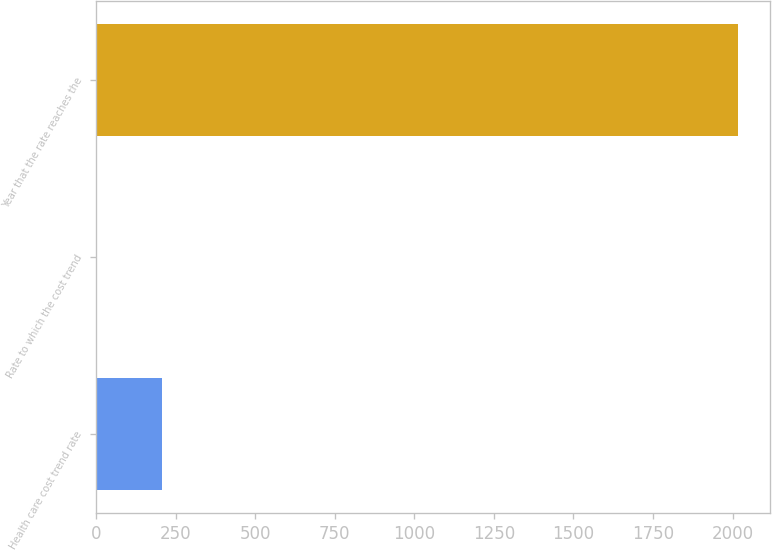<chart> <loc_0><loc_0><loc_500><loc_500><bar_chart><fcel>Health care cost trend rate<fcel>Rate to which the cost trend<fcel>Year that the rate reaches the<nl><fcel>205.84<fcel>4.49<fcel>2018<nl></chart> 